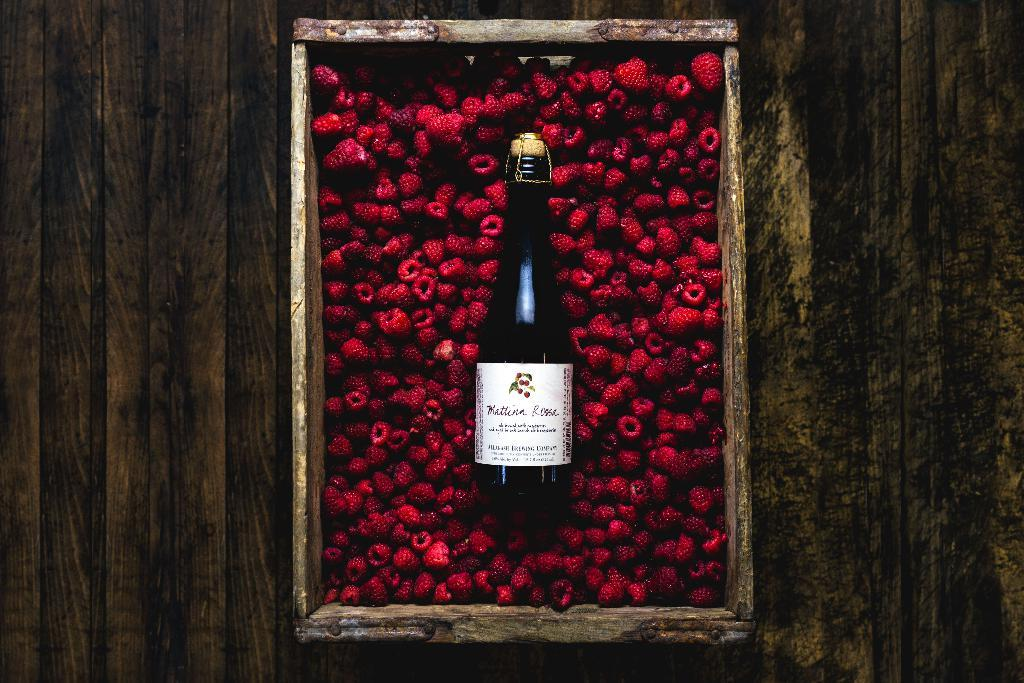<image>
Write a terse but informative summary of the picture. A bottle of Kattina Rossa wine sits in a box of berries. 